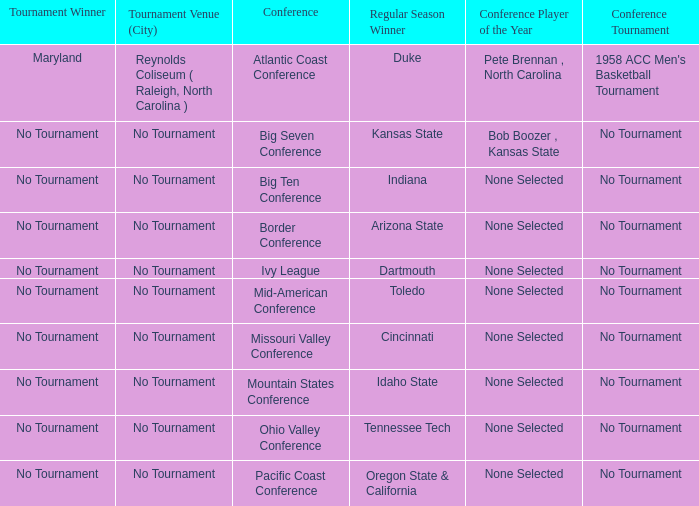Who is the tournament winner in the Atlantic Coast Conference? Maryland. 